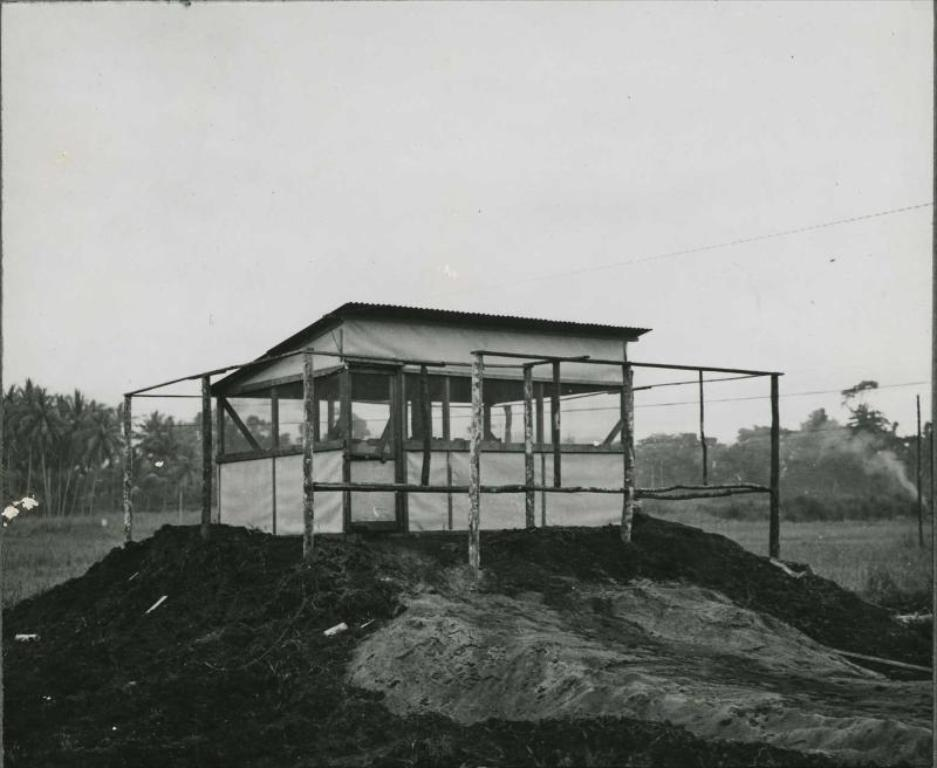What structures can be seen in the image? There are poles and a shed in the image. What type of vegetation is present in the image? There is grass and trees in the image. What can be seen coming from the shed in the image? There is smoke coming from the shed in the image. What is visible in the background of the image? The sky is visible in the background of the image. How does the bear guide the poles in the image? There is no bear present in the image, and therefore no such guiding can be observed. 